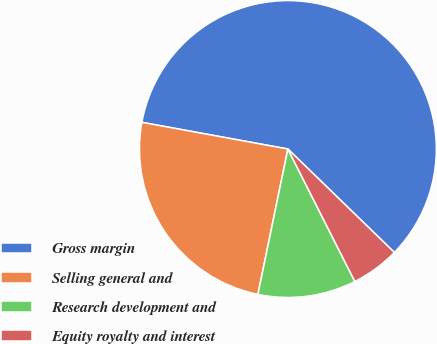<chart> <loc_0><loc_0><loc_500><loc_500><pie_chart><fcel>Gross margin<fcel>Selling general and<fcel>Research development and<fcel>Equity royalty and interest<nl><fcel>59.39%<fcel>24.64%<fcel>10.69%<fcel>5.28%<nl></chart> 